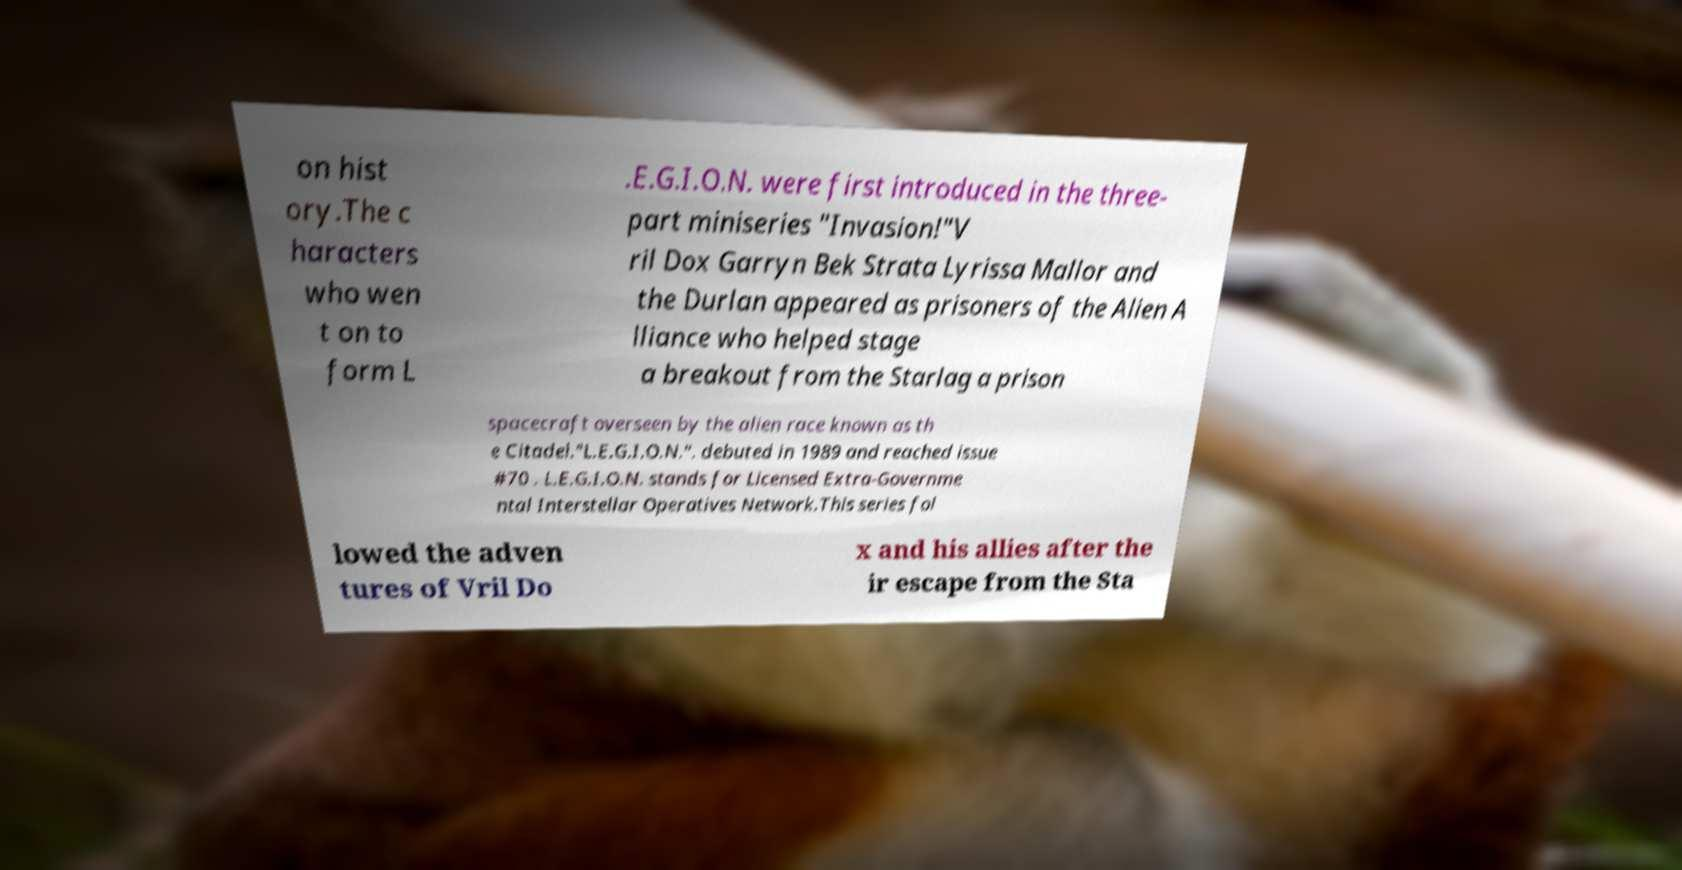I need the written content from this picture converted into text. Can you do that? on hist ory.The c haracters who wen t on to form L .E.G.I.O.N. were first introduced in the three- part miniseries "Invasion!"V ril Dox Garryn Bek Strata Lyrissa Mallor and the Durlan appeared as prisoners of the Alien A lliance who helped stage a breakout from the Starlag a prison spacecraft overseen by the alien race known as th e Citadel."L.E.G.I.O.N.". debuted in 1989 and reached issue #70 . L.E.G.I.O.N. stands for Licensed Extra-Governme ntal Interstellar Operatives Network.This series fol lowed the adven tures of Vril Do x and his allies after the ir escape from the Sta 